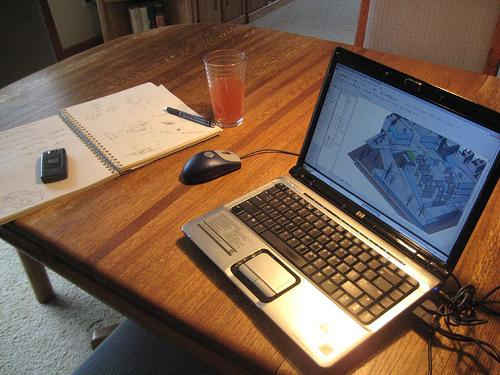What is the computer most at risk of? spill 